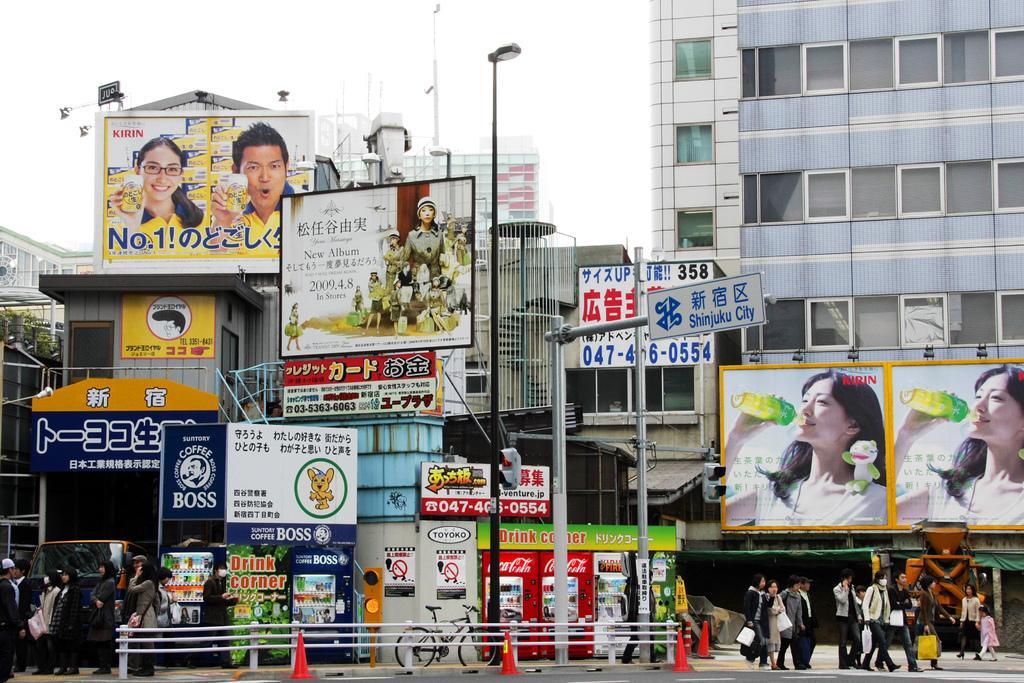In one or two sentences, can you explain what this image depicts? As we can see in the image there are buildings, banners, bicycle, traffic cones, group of people, street lamp, traffic signals and at the top there is sky. 